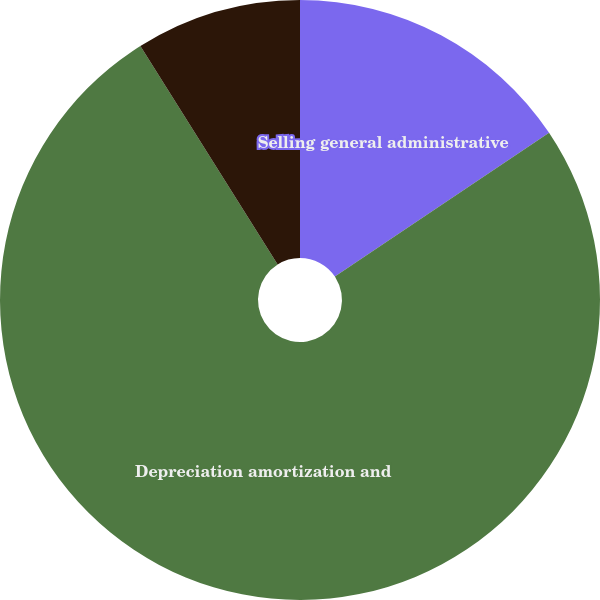<chart> <loc_0><loc_0><loc_500><loc_500><pie_chart><fcel>Selling general administrative<fcel>Depreciation amortization and<fcel>Capital<nl><fcel>15.59%<fcel>75.48%<fcel>8.93%<nl></chart> 